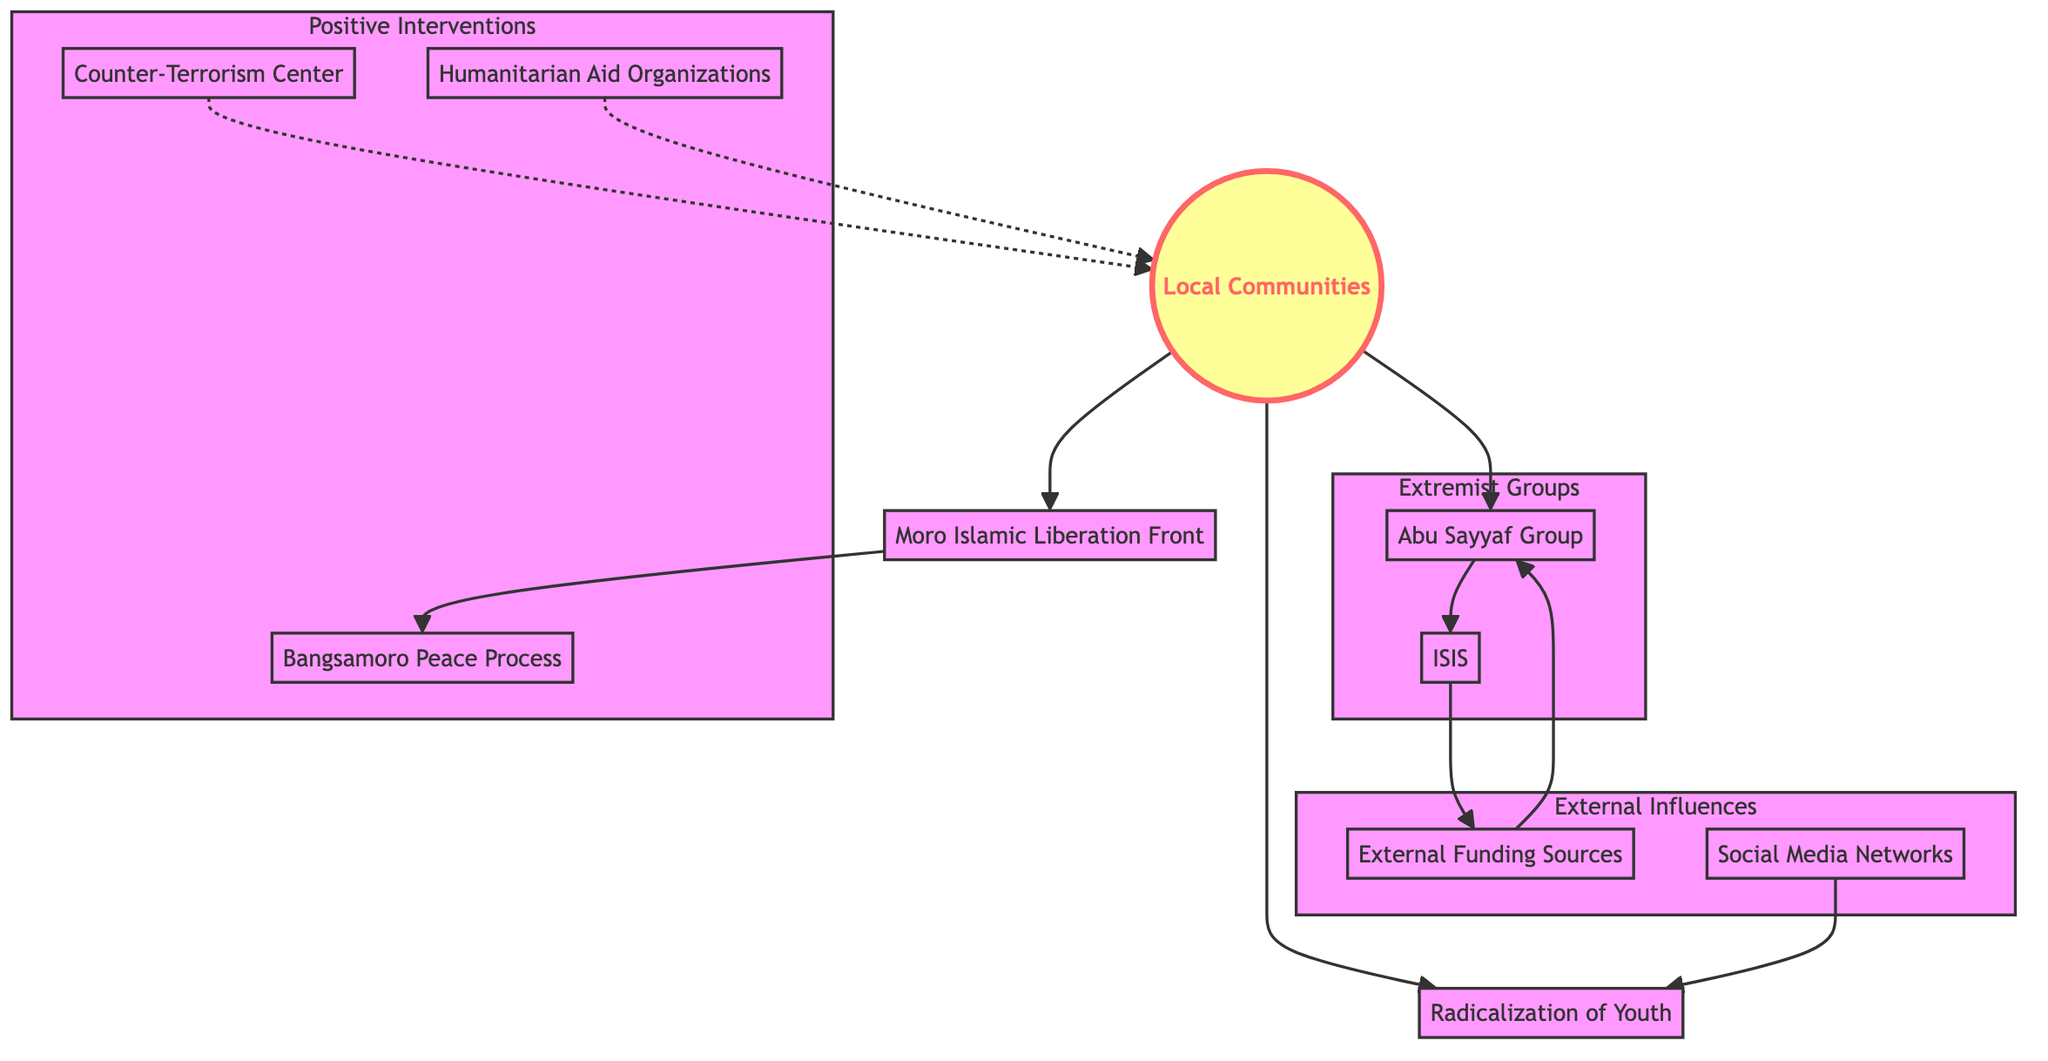What is the total number of nodes in the diagram? The diagram includes the following nodes: Local Communities, Moro Islamic Liberation Front, Abu Sayyaf Group, ISIS, Counter-Terrorism Center, Bangsamoro Peace Process, External Funding Sources, Radicalization of Youth, Social Media Networks, and Humanitarian Aid Organizations. Counting these gives a total of 10 nodes.
Answer: 10 What is the relationship between Local Communities and MILF? The diagram shows a directed edge from Local Communities to MILF, indicating that Local Communities are connected to or have influence over the Moro Islamic Liberation Front.
Answer: Influence Which groups are part of the Extremist Groups subgraph? The Extremist Groups subgraph includes Abu Sayyaf Group and ISIS. These are the only two nodes encapsulated within that subgraph, indicating their classification as extremist groups.
Answer: Abu Sayyaf Group, ISIS How many edges are directed from Local Communities? The Local Communities node has three directed edges leading to Moro Islamic Liberation Front, Abu Sayyaf Group, and Radicalization of Youth. Therefore, it has a total of 3 edges directed from it.
Answer: 3 What type of organizations are linked to Local Communities through a dotted line? The diagram includes two nodes connected to Local Communities through dotted lines: Counter-Terrorism Center and Humanitarian Aid Organizations. The dotted lines represent a less direct or supportive relationship.
Answer: Counter-Terrorism Center, Humanitarian Aid Organizations Which group is funded externally according to the diagram? The diagram indicates that ISIS is linked to External Funding, suggesting that it receives financial support from outside sources.
Answer: ISIS How does Social Media contribute to Radicalization? The directed edge from Social Media to Radicalization of Youth indicates that Social Media Networks are a contributing factor to the process of radicalization among youth in Local Communities.
Answer: Contributing factor Which two organizations are part of Positive Interventions? The Positive Interventions subgraph includes the Counter-Terrorism Center and Humanitarian Aid Organizations, indicating their role in addressing community issues positively.
Answer: Counter-Terrorism Center, Humanitarian Aid Organizations What is the primary group associated with the Bangsamoro Peace Process? The Moro Islamic Liberation Front is directly connected to the Bangsamoro Peace Process by an edge, establishing its role in this peace initiative.
Answer: Moro Islamic Liberation Front 